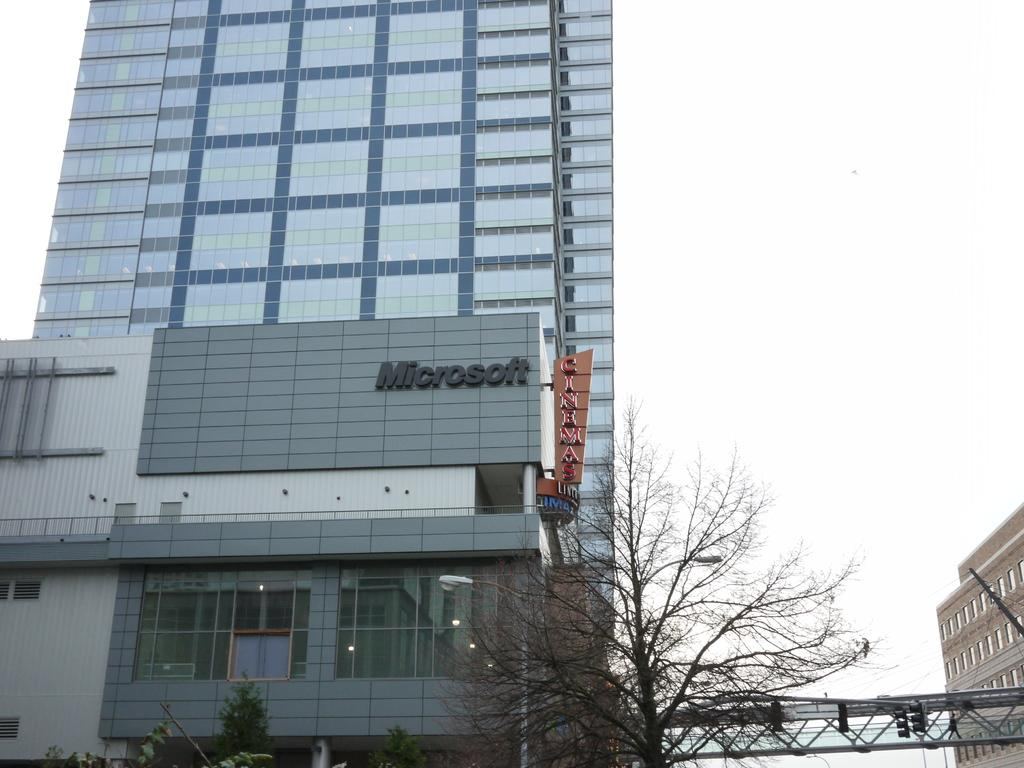What type of structures can be seen in the image? There are buildings in the image. What natural element is present in the image? There is a tree in the image. What type of man-made structure is visible in the image? There is a bridge in the image. What is visible in the background of the image? The sky is visible in the image. Can you tell me how many toes are visible on the tree in the image? There are no toes present in the image, as it features buildings, a tree, a bridge, and the sky. What type of jam is being spread on the bridge in the image? There is no jam present in the image; it features buildings, a tree, a bridge, and the sky. 